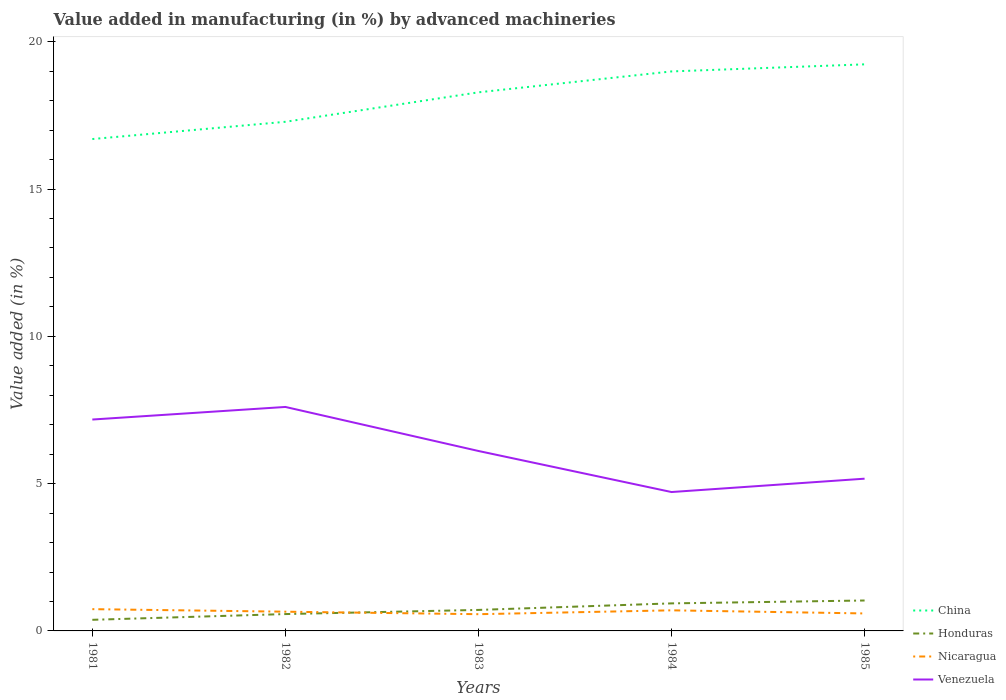How many different coloured lines are there?
Offer a very short reply. 4. Is the number of lines equal to the number of legend labels?
Your response must be concise. Yes. Across all years, what is the maximum percentage of value added in manufacturing by advanced machineries in Honduras?
Make the answer very short. 0.38. What is the total percentage of value added in manufacturing by advanced machineries in China in the graph?
Give a very brief answer. -2.54. What is the difference between the highest and the second highest percentage of value added in manufacturing by advanced machineries in Honduras?
Your answer should be very brief. 0.66. What is the difference between the highest and the lowest percentage of value added in manufacturing by advanced machineries in Venezuela?
Offer a terse response. 2. Is the percentage of value added in manufacturing by advanced machineries in Venezuela strictly greater than the percentage of value added in manufacturing by advanced machineries in Nicaragua over the years?
Your answer should be very brief. No. How many lines are there?
Give a very brief answer. 4. How many years are there in the graph?
Provide a short and direct response. 5. Are the values on the major ticks of Y-axis written in scientific E-notation?
Your response must be concise. No. Where does the legend appear in the graph?
Offer a terse response. Bottom right. How many legend labels are there?
Keep it short and to the point. 4. What is the title of the graph?
Provide a succinct answer. Value added in manufacturing (in %) by advanced machineries. What is the label or title of the X-axis?
Provide a short and direct response. Years. What is the label or title of the Y-axis?
Offer a very short reply. Value added (in %). What is the Value added (in %) in China in 1981?
Offer a terse response. 16.7. What is the Value added (in %) in Honduras in 1981?
Your response must be concise. 0.38. What is the Value added (in %) in Nicaragua in 1981?
Offer a terse response. 0.74. What is the Value added (in %) of Venezuela in 1981?
Keep it short and to the point. 7.18. What is the Value added (in %) of China in 1982?
Provide a succinct answer. 17.28. What is the Value added (in %) of Honduras in 1982?
Provide a succinct answer. 0.57. What is the Value added (in %) in Nicaragua in 1982?
Provide a succinct answer. 0.65. What is the Value added (in %) of Venezuela in 1982?
Offer a very short reply. 7.6. What is the Value added (in %) of China in 1983?
Your response must be concise. 18.28. What is the Value added (in %) in Honduras in 1983?
Offer a terse response. 0.71. What is the Value added (in %) in Nicaragua in 1983?
Provide a succinct answer. 0.57. What is the Value added (in %) in Venezuela in 1983?
Ensure brevity in your answer.  6.11. What is the Value added (in %) in China in 1984?
Provide a succinct answer. 18.99. What is the Value added (in %) of Honduras in 1984?
Keep it short and to the point. 0.93. What is the Value added (in %) in Nicaragua in 1984?
Provide a succinct answer. 0.7. What is the Value added (in %) in Venezuela in 1984?
Give a very brief answer. 4.71. What is the Value added (in %) of China in 1985?
Provide a short and direct response. 19.23. What is the Value added (in %) of Honduras in 1985?
Make the answer very short. 1.03. What is the Value added (in %) of Nicaragua in 1985?
Give a very brief answer. 0.59. What is the Value added (in %) of Venezuela in 1985?
Offer a very short reply. 5.17. Across all years, what is the maximum Value added (in %) of China?
Provide a succinct answer. 19.23. Across all years, what is the maximum Value added (in %) in Honduras?
Make the answer very short. 1.03. Across all years, what is the maximum Value added (in %) in Nicaragua?
Keep it short and to the point. 0.74. Across all years, what is the maximum Value added (in %) of Venezuela?
Provide a short and direct response. 7.6. Across all years, what is the minimum Value added (in %) of China?
Your response must be concise. 16.7. Across all years, what is the minimum Value added (in %) of Honduras?
Offer a very short reply. 0.38. Across all years, what is the minimum Value added (in %) of Nicaragua?
Make the answer very short. 0.57. Across all years, what is the minimum Value added (in %) of Venezuela?
Your response must be concise. 4.71. What is the total Value added (in %) in China in the graph?
Give a very brief answer. 90.49. What is the total Value added (in %) in Honduras in the graph?
Give a very brief answer. 3.63. What is the total Value added (in %) of Nicaragua in the graph?
Offer a terse response. 3.25. What is the total Value added (in %) in Venezuela in the graph?
Ensure brevity in your answer.  30.77. What is the difference between the Value added (in %) in China in 1981 and that in 1982?
Provide a succinct answer. -0.59. What is the difference between the Value added (in %) of Honduras in 1981 and that in 1982?
Your answer should be very brief. -0.19. What is the difference between the Value added (in %) of Nicaragua in 1981 and that in 1982?
Provide a short and direct response. 0.09. What is the difference between the Value added (in %) in Venezuela in 1981 and that in 1982?
Offer a terse response. -0.43. What is the difference between the Value added (in %) in China in 1981 and that in 1983?
Offer a terse response. -1.59. What is the difference between the Value added (in %) in Honduras in 1981 and that in 1983?
Your answer should be compact. -0.34. What is the difference between the Value added (in %) in Nicaragua in 1981 and that in 1983?
Your answer should be very brief. 0.17. What is the difference between the Value added (in %) of Venezuela in 1981 and that in 1983?
Offer a terse response. 1.07. What is the difference between the Value added (in %) in China in 1981 and that in 1984?
Keep it short and to the point. -2.3. What is the difference between the Value added (in %) of Honduras in 1981 and that in 1984?
Provide a short and direct response. -0.56. What is the difference between the Value added (in %) of Nicaragua in 1981 and that in 1984?
Give a very brief answer. 0.04. What is the difference between the Value added (in %) of Venezuela in 1981 and that in 1984?
Provide a succinct answer. 2.46. What is the difference between the Value added (in %) of China in 1981 and that in 1985?
Your answer should be compact. -2.54. What is the difference between the Value added (in %) of Honduras in 1981 and that in 1985?
Offer a very short reply. -0.66. What is the difference between the Value added (in %) in Nicaragua in 1981 and that in 1985?
Provide a short and direct response. 0.15. What is the difference between the Value added (in %) in Venezuela in 1981 and that in 1985?
Offer a very short reply. 2.01. What is the difference between the Value added (in %) of China in 1982 and that in 1983?
Keep it short and to the point. -1. What is the difference between the Value added (in %) in Honduras in 1982 and that in 1983?
Offer a terse response. -0.14. What is the difference between the Value added (in %) in Nicaragua in 1982 and that in 1983?
Offer a very short reply. 0.08. What is the difference between the Value added (in %) of Venezuela in 1982 and that in 1983?
Give a very brief answer. 1.5. What is the difference between the Value added (in %) of China in 1982 and that in 1984?
Ensure brevity in your answer.  -1.71. What is the difference between the Value added (in %) in Honduras in 1982 and that in 1984?
Offer a terse response. -0.36. What is the difference between the Value added (in %) of Nicaragua in 1982 and that in 1984?
Your answer should be compact. -0.05. What is the difference between the Value added (in %) of Venezuela in 1982 and that in 1984?
Your answer should be very brief. 2.89. What is the difference between the Value added (in %) in China in 1982 and that in 1985?
Give a very brief answer. -1.95. What is the difference between the Value added (in %) in Honduras in 1982 and that in 1985?
Offer a very short reply. -0.46. What is the difference between the Value added (in %) of Nicaragua in 1982 and that in 1985?
Make the answer very short. 0.06. What is the difference between the Value added (in %) in Venezuela in 1982 and that in 1985?
Give a very brief answer. 2.44. What is the difference between the Value added (in %) in China in 1983 and that in 1984?
Your answer should be very brief. -0.71. What is the difference between the Value added (in %) in Honduras in 1983 and that in 1984?
Provide a succinct answer. -0.22. What is the difference between the Value added (in %) of Nicaragua in 1983 and that in 1984?
Give a very brief answer. -0.13. What is the difference between the Value added (in %) of Venezuela in 1983 and that in 1984?
Offer a very short reply. 1.39. What is the difference between the Value added (in %) of China in 1983 and that in 1985?
Give a very brief answer. -0.95. What is the difference between the Value added (in %) of Honduras in 1983 and that in 1985?
Make the answer very short. -0.32. What is the difference between the Value added (in %) in Nicaragua in 1983 and that in 1985?
Offer a terse response. -0.03. What is the difference between the Value added (in %) of Venezuela in 1983 and that in 1985?
Ensure brevity in your answer.  0.94. What is the difference between the Value added (in %) in China in 1984 and that in 1985?
Your answer should be compact. -0.24. What is the difference between the Value added (in %) in Honduras in 1984 and that in 1985?
Give a very brief answer. -0.1. What is the difference between the Value added (in %) in Nicaragua in 1984 and that in 1985?
Your answer should be very brief. 0.11. What is the difference between the Value added (in %) in Venezuela in 1984 and that in 1985?
Your response must be concise. -0.45. What is the difference between the Value added (in %) in China in 1981 and the Value added (in %) in Honduras in 1982?
Ensure brevity in your answer.  16.13. What is the difference between the Value added (in %) of China in 1981 and the Value added (in %) of Nicaragua in 1982?
Your answer should be very brief. 16.05. What is the difference between the Value added (in %) of China in 1981 and the Value added (in %) of Venezuela in 1982?
Provide a succinct answer. 9.09. What is the difference between the Value added (in %) of Honduras in 1981 and the Value added (in %) of Nicaragua in 1982?
Keep it short and to the point. -0.28. What is the difference between the Value added (in %) of Honduras in 1981 and the Value added (in %) of Venezuela in 1982?
Offer a terse response. -7.23. What is the difference between the Value added (in %) of Nicaragua in 1981 and the Value added (in %) of Venezuela in 1982?
Your response must be concise. -6.86. What is the difference between the Value added (in %) in China in 1981 and the Value added (in %) in Honduras in 1983?
Give a very brief answer. 15.98. What is the difference between the Value added (in %) of China in 1981 and the Value added (in %) of Nicaragua in 1983?
Provide a succinct answer. 16.13. What is the difference between the Value added (in %) of China in 1981 and the Value added (in %) of Venezuela in 1983?
Your answer should be compact. 10.59. What is the difference between the Value added (in %) of Honduras in 1981 and the Value added (in %) of Nicaragua in 1983?
Ensure brevity in your answer.  -0.19. What is the difference between the Value added (in %) of Honduras in 1981 and the Value added (in %) of Venezuela in 1983?
Provide a succinct answer. -5.73. What is the difference between the Value added (in %) of Nicaragua in 1981 and the Value added (in %) of Venezuela in 1983?
Provide a short and direct response. -5.37. What is the difference between the Value added (in %) of China in 1981 and the Value added (in %) of Honduras in 1984?
Provide a short and direct response. 15.76. What is the difference between the Value added (in %) of China in 1981 and the Value added (in %) of Nicaragua in 1984?
Keep it short and to the point. 16. What is the difference between the Value added (in %) in China in 1981 and the Value added (in %) in Venezuela in 1984?
Ensure brevity in your answer.  11.98. What is the difference between the Value added (in %) of Honduras in 1981 and the Value added (in %) of Nicaragua in 1984?
Provide a succinct answer. -0.32. What is the difference between the Value added (in %) in Honduras in 1981 and the Value added (in %) in Venezuela in 1984?
Give a very brief answer. -4.34. What is the difference between the Value added (in %) in Nicaragua in 1981 and the Value added (in %) in Venezuela in 1984?
Make the answer very short. -3.98. What is the difference between the Value added (in %) in China in 1981 and the Value added (in %) in Honduras in 1985?
Your response must be concise. 15.66. What is the difference between the Value added (in %) of China in 1981 and the Value added (in %) of Nicaragua in 1985?
Your answer should be compact. 16.1. What is the difference between the Value added (in %) in China in 1981 and the Value added (in %) in Venezuela in 1985?
Ensure brevity in your answer.  11.53. What is the difference between the Value added (in %) in Honduras in 1981 and the Value added (in %) in Nicaragua in 1985?
Keep it short and to the point. -0.22. What is the difference between the Value added (in %) of Honduras in 1981 and the Value added (in %) of Venezuela in 1985?
Your answer should be very brief. -4.79. What is the difference between the Value added (in %) in Nicaragua in 1981 and the Value added (in %) in Venezuela in 1985?
Your answer should be compact. -4.43. What is the difference between the Value added (in %) of China in 1982 and the Value added (in %) of Honduras in 1983?
Ensure brevity in your answer.  16.57. What is the difference between the Value added (in %) in China in 1982 and the Value added (in %) in Nicaragua in 1983?
Your answer should be compact. 16.72. What is the difference between the Value added (in %) of China in 1982 and the Value added (in %) of Venezuela in 1983?
Provide a succinct answer. 11.18. What is the difference between the Value added (in %) in Honduras in 1982 and the Value added (in %) in Nicaragua in 1983?
Give a very brief answer. 0. What is the difference between the Value added (in %) in Honduras in 1982 and the Value added (in %) in Venezuela in 1983?
Ensure brevity in your answer.  -5.54. What is the difference between the Value added (in %) of Nicaragua in 1982 and the Value added (in %) of Venezuela in 1983?
Provide a short and direct response. -5.46. What is the difference between the Value added (in %) of China in 1982 and the Value added (in %) of Honduras in 1984?
Give a very brief answer. 16.35. What is the difference between the Value added (in %) in China in 1982 and the Value added (in %) in Nicaragua in 1984?
Ensure brevity in your answer.  16.58. What is the difference between the Value added (in %) in China in 1982 and the Value added (in %) in Venezuela in 1984?
Provide a short and direct response. 12.57. What is the difference between the Value added (in %) of Honduras in 1982 and the Value added (in %) of Nicaragua in 1984?
Offer a terse response. -0.13. What is the difference between the Value added (in %) in Honduras in 1982 and the Value added (in %) in Venezuela in 1984?
Provide a succinct answer. -4.14. What is the difference between the Value added (in %) in Nicaragua in 1982 and the Value added (in %) in Venezuela in 1984?
Offer a very short reply. -4.06. What is the difference between the Value added (in %) in China in 1982 and the Value added (in %) in Honduras in 1985?
Provide a short and direct response. 16.25. What is the difference between the Value added (in %) of China in 1982 and the Value added (in %) of Nicaragua in 1985?
Your answer should be very brief. 16.69. What is the difference between the Value added (in %) of China in 1982 and the Value added (in %) of Venezuela in 1985?
Give a very brief answer. 12.12. What is the difference between the Value added (in %) of Honduras in 1982 and the Value added (in %) of Nicaragua in 1985?
Keep it short and to the point. -0.02. What is the difference between the Value added (in %) in Honduras in 1982 and the Value added (in %) in Venezuela in 1985?
Keep it short and to the point. -4.6. What is the difference between the Value added (in %) of Nicaragua in 1982 and the Value added (in %) of Venezuela in 1985?
Make the answer very short. -4.52. What is the difference between the Value added (in %) of China in 1983 and the Value added (in %) of Honduras in 1984?
Your answer should be compact. 17.35. What is the difference between the Value added (in %) of China in 1983 and the Value added (in %) of Nicaragua in 1984?
Keep it short and to the point. 17.58. What is the difference between the Value added (in %) of China in 1983 and the Value added (in %) of Venezuela in 1984?
Offer a very short reply. 13.57. What is the difference between the Value added (in %) in Honduras in 1983 and the Value added (in %) in Nicaragua in 1984?
Your response must be concise. 0.01. What is the difference between the Value added (in %) of Honduras in 1983 and the Value added (in %) of Venezuela in 1984?
Give a very brief answer. -4. What is the difference between the Value added (in %) of Nicaragua in 1983 and the Value added (in %) of Venezuela in 1984?
Ensure brevity in your answer.  -4.15. What is the difference between the Value added (in %) of China in 1983 and the Value added (in %) of Honduras in 1985?
Offer a terse response. 17.25. What is the difference between the Value added (in %) of China in 1983 and the Value added (in %) of Nicaragua in 1985?
Offer a very short reply. 17.69. What is the difference between the Value added (in %) of China in 1983 and the Value added (in %) of Venezuela in 1985?
Provide a succinct answer. 13.12. What is the difference between the Value added (in %) in Honduras in 1983 and the Value added (in %) in Nicaragua in 1985?
Your answer should be compact. 0.12. What is the difference between the Value added (in %) of Honduras in 1983 and the Value added (in %) of Venezuela in 1985?
Keep it short and to the point. -4.46. What is the difference between the Value added (in %) in Nicaragua in 1983 and the Value added (in %) in Venezuela in 1985?
Provide a succinct answer. -4.6. What is the difference between the Value added (in %) in China in 1984 and the Value added (in %) in Honduras in 1985?
Offer a very short reply. 17.96. What is the difference between the Value added (in %) of China in 1984 and the Value added (in %) of Nicaragua in 1985?
Provide a short and direct response. 18.4. What is the difference between the Value added (in %) of China in 1984 and the Value added (in %) of Venezuela in 1985?
Offer a very short reply. 13.83. What is the difference between the Value added (in %) in Honduras in 1984 and the Value added (in %) in Nicaragua in 1985?
Provide a short and direct response. 0.34. What is the difference between the Value added (in %) in Honduras in 1984 and the Value added (in %) in Venezuela in 1985?
Offer a terse response. -4.23. What is the difference between the Value added (in %) of Nicaragua in 1984 and the Value added (in %) of Venezuela in 1985?
Provide a succinct answer. -4.47. What is the average Value added (in %) of China per year?
Ensure brevity in your answer.  18.1. What is the average Value added (in %) of Honduras per year?
Your answer should be compact. 0.73. What is the average Value added (in %) in Nicaragua per year?
Your response must be concise. 0.65. What is the average Value added (in %) in Venezuela per year?
Ensure brevity in your answer.  6.15. In the year 1981, what is the difference between the Value added (in %) in China and Value added (in %) in Honduras?
Provide a short and direct response. 16.32. In the year 1981, what is the difference between the Value added (in %) in China and Value added (in %) in Nicaragua?
Ensure brevity in your answer.  15.96. In the year 1981, what is the difference between the Value added (in %) of China and Value added (in %) of Venezuela?
Make the answer very short. 9.52. In the year 1981, what is the difference between the Value added (in %) of Honduras and Value added (in %) of Nicaragua?
Keep it short and to the point. -0.36. In the year 1981, what is the difference between the Value added (in %) of Honduras and Value added (in %) of Venezuela?
Your answer should be very brief. -6.8. In the year 1981, what is the difference between the Value added (in %) in Nicaragua and Value added (in %) in Venezuela?
Keep it short and to the point. -6.44. In the year 1982, what is the difference between the Value added (in %) of China and Value added (in %) of Honduras?
Provide a short and direct response. 16.71. In the year 1982, what is the difference between the Value added (in %) in China and Value added (in %) in Nicaragua?
Keep it short and to the point. 16.63. In the year 1982, what is the difference between the Value added (in %) in China and Value added (in %) in Venezuela?
Provide a short and direct response. 9.68. In the year 1982, what is the difference between the Value added (in %) of Honduras and Value added (in %) of Nicaragua?
Give a very brief answer. -0.08. In the year 1982, what is the difference between the Value added (in %) of Honduras and Value added (in %) of Venezuela?
Ensure brevity in your answer.  -7.03. In the year 1982, what is the difference between the Value added (in %) in Nicaragua and Value added (in %) in Venezuela?
Ensure brevity in your answer.  -6.95. In the year 1983, what is the difference between the Value added (in %) of China and Value added (in %) of Honduras?
Offer a terse response. 17.57. In the year 1983, what is the difference between the Value added (in %) in China and Value added (in %) in Nicaragua?
Offer a terse response. 17.72. In the year 1983, what is the difference between the Value added (in %) in China and Value added (in %) in Venezuela?
Your answer should be very brief. 12.18. In the year 1983, what is the difference between the Value added (in %) in Honduras and Value added (in %) in Nicaragua?
Keep it short and to the point. 0.14. In the year 1983, what is the difference between the Value added (in %) of Honduras and Value added (in %) of Venezuela?
Your answer should be compact. -5.4. In the year 1983, what is the difference between the Value added (in %) of Nicaragua and Value added (in %) of Venezuela?
Your response must be concise. -5.54. In the year 1984, what is the difference between the Value added (in %) of China and Value added (in %) of Honduras?
Give a very brief answer. 18.06. In the year 1984, what is the difference between the Value added (in %) in China and Value added (in %) in Nicaragua?
Keep it short and to the point. 18.29. In the year 1984, what is the difference between the Value added (in %) of China and Value added (in %) of Venezuela?
Keep it short and to the point. 14.28. In the year 1984, what is the difference between the Value added (in %) in Honduras and Value added (in %) in Nicaragua?
Your response must be concise. 0.24. In the year 1984, what is the difference between the Value added (in %) in Honduras and Value added (in %) in Venezuela?
Make the answer very short. -3.78. In the year 1984, what is the difference between the Value added (in %) in Nicaragua and Value added (in %) in Venezuela?
Offer a terse response. -4.02. In the year 1985, what is the difference between the Value added (in %) of China and Value added (in %) of Honduras?
Provide a short and direct response. 18.2. In the year 1985, what is the difference between the Value added (in %) of China and Value added (in %) of Nicaragua?
Provide a succinct answer. 18.64. In the year 1985, what is the difference between the Value added (in %) in China and Value added (in %) in Venezuela?
Keep it short and to the point. 14.07. In the year 1985, what is the difference between the Value added (in %) of Honduras and Value added (in %) of Nicaragua?
Your answer should be very brief. 0.44. In the year 1985, what is the difference between the Value added (in %) of Honduras and Value added (in %) of Venezuela?
Your answer should be very brief. -4.14. In the year 1985, what is the difference between the Value added (in %) in Nicaragua and Value added (in %) in Venezuela?
Offer a terse response. -4.57. What is the ratio of the Value added (in %) of China in 1981 to that in 1982?
Provide a short and direct response. 0.97. What is the ratio of the Value added (in %) in Honduras in 1981 to that in 1982?
Make the answer very short. 0.66. What is the ratio of the Value added (in %) of Nicaragua in 1981 to that in 1982?
Your response must be concise. 1.13. What is the ratio of the Value added (in %) in Venezuela in 1981 to that in 1982?
Provide a succinct answer. 0.94. What is the ratio of the Value added (in %) in China in 1981 to that in 1983?
Make the answer very short. 0.91. What is the ratio of the Value added (in %) of Honduras in 1981 to that in 1983?
Your answer should be very brief. 0.53. What is the ratio of the Value added (in %) of Nicaragua in 1981 to that in 1983?
Keep it short and to the point. 1.3. What is the ratio of the Value added (in %) in Venezuela in 1981 to that in 1983?
Keep it short and to the point. 1.17. What is the ratio of the Value added (in %) of China in 1981 to that in 1984?
Offer a very short reply. 0.88. What is the ratio of the Value added (in %) of Honduras in 1981 to that in 1984?
Offer a terse response. 0.4. What is the ratio of the Value added (in %) in Nicaragua in 1981 to that in 1984?
Your answer should be very brief. 1.06. What is the ratio of the Value added (in %) in Venezuela in 1981 to that in 1984?
Keep it short and to the point. 1.52. What is the ratio of the Value added (in %) of China in 1981 to that in 1985?
Keep it short and to the point. 0.87. What is the ratio of the Value added (in %) of Honduras in 1981 to that in 1985?
Keep it short and to the point. 0.37. What is the ratio of the Value added (in %) in Nicaragua in 1981 to that in 1985?
Your answer should be compact. 1.25. What is the ratio of the Value added (in %) of Venezuela in 1981 to that in 1985?
Your answer should be compact. 1.39. What is the ratio of the Value added (in %) of China in 1982 to that in 1983?
Ensure brevity in your answer.  0.95. What is the ratio of the Value added (in %) in Honduras in 1982 to that in 1983?
Offer a very short reply. 0.8. What is the ratio of the Value added (in %) in Nicaragua in 1982 to that in 1983?
Keep it short and to the point. 1.15. What is the ratio of the Value added (in %) of Venezuela in 1982 to that in 1983?
Make the answer very short. 1.24. What is the ratio of the Value added (in %) in China in 1982 to that in 1984?
Offer a very short reply. 0.91. What is the ratio of the Value added (in %) of Honduras in 1982 to that in 1984?
Make the answer very short. 0.61. What is the ratio of the Value added (in %) of Nicaragua in 1982 to that in 1984?
Your response must be concise. 0.93. What is the ratio of the Value added (in %) of Venezuela in 1982 to that in 1984?
Provide a succinct answer. 1.61. What is the ratio of the Value added (in %) of China in 1982 to that in 1985?
Give a very brief answer. 0.9. What is the ratio of the Value added (in %) in Honduras in 1982 to that in 1985?
Provide a short and direct response. 0.55. What is the ratio of the Value added (in %) in Nicaragua in 1982 to that in 1985?
Ensure brevity in your answer.  1.1. What is the ratio of the Value added (in %) in Venezuela in 1982 to that in 1985?
Offer a very short reply. 1.47. What is the ratio of the Value added (in %) of China in 1983 to that in 1984?
Offer a terse response. 0.96. What is the ratio of the Value added (in %) of Honduras in 1983 to that in 1984?
Make the answer very short. 0.76. What is the ratio of the Value added (in %) in Nicaragua in 1983 to that in 1984?
Give a very brief answer. 0.81. What is the ratio of the Value added (in %) in Venezuela in 1983 to that in 1984?
Your response must be concise. 1.3. What is the ratio of the Value added (in %) of China in 1983 to that in 1985?
Provide a succinct answer. 0.95. What is the ratio of the Value added (in %) of Honduras in 1983 to that in 1985?
Provide a succinct answer. 0.69. What is the ratio of the Value added (in %) of Nicaragua in 1983 to that in 1985?
Make the answer very short. 0.96. What is the ratio of the Value added (in %) of Venezuela in 1983 to that in 1985?
Make the answer very short. 1.18. What is the ratio of the Value added (in %) in China in 1984 to that in 1985?
Your answer should be very brief. 0.99. What is the ratio of the Value added (in %) of Honduras in 1984 to that in 1985?
Provide a succinct answer. 0.91. What is the ratio of the Value added (in %) in Nicaragua in 1984 to that in 1985?
Ensure brevity in your answer.  1.18. What is the ratio of the Value added (in %) in Venezuela in 1984 to that in 1985?
Your answer should be compact. 0.91. What is the difference between the highest and the second highest Value added (in %) of China?
Make the answer very short. 0.24. What is the difference between the highest and the second highest Value added (in %) in Honduras?
Give a very brief answer. 0.1. What is the difference between the highest and the second highest Value added (in %) in Nicaragua?
Ensure brevity in your answer.  0.04. What is the difference between the highest and the second highest Value added (in %) of Venezuela?
Ensure brevity in your answer.  0.43. What is the difference between the highest and the lowest Value added (in %) of China?
Offer a terse response. 2.54. What is the difference between the highest and the lowest Value added (in %) in Honduras?
Offer a very short reply. 0.66. What is the difference between the highest and the lowest Value added (in %) in Nicaragua?
Keep it short and to the point. 0.17. What is the difference between the highest and the lowest Value added (in %) in Venezuela?
Your answer should be very brief. 2.89. 